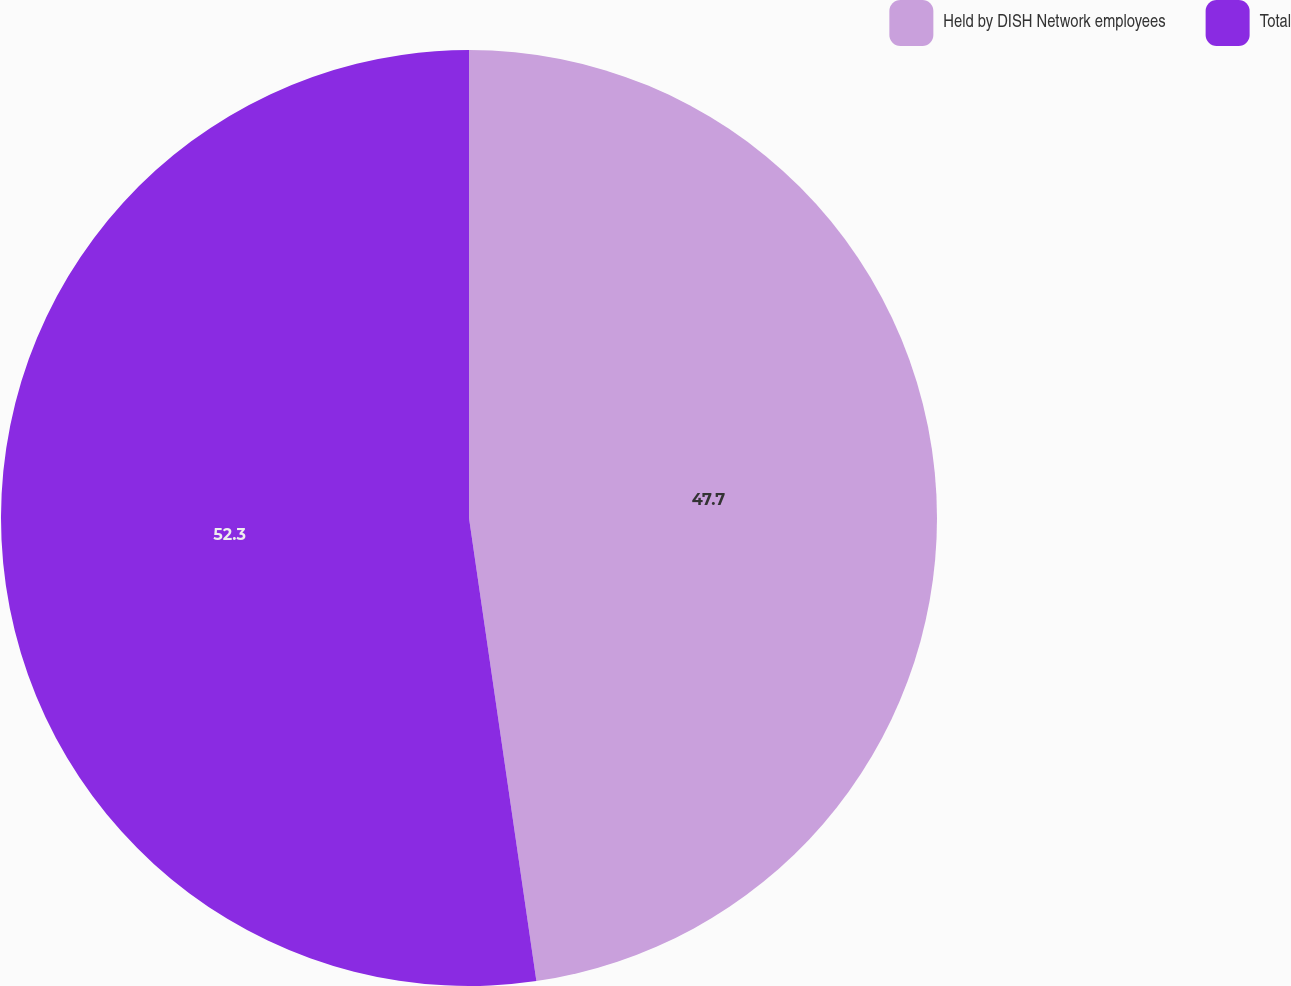Convert chart. <chart><loc_0><loc_0><loc_500><loc_500><pie_chart><fcel>Held by DISH Network employees<fcel>Total<nl><fcel>47.7%<fcel>52.3%<nl></chart> 